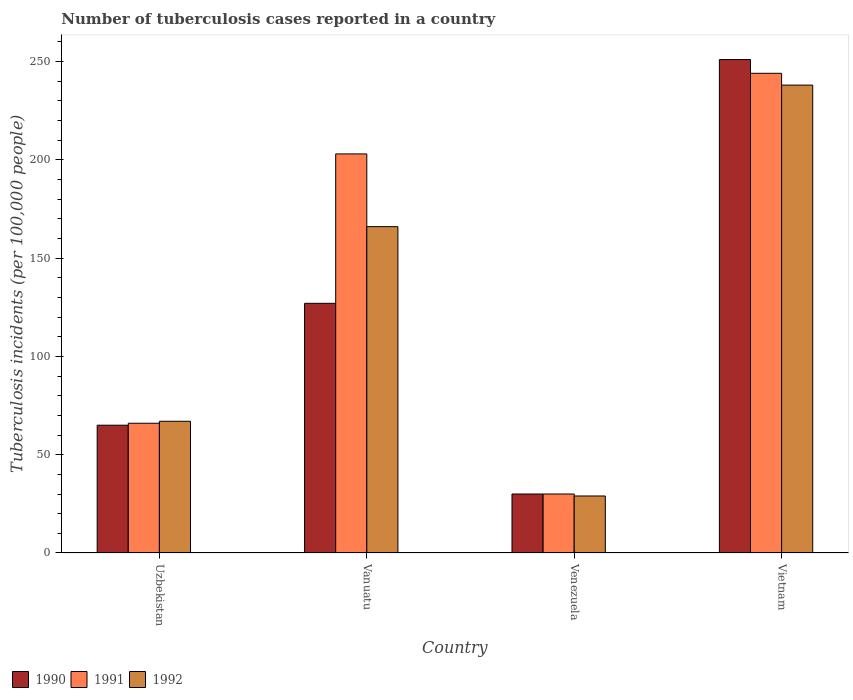How many different coloured bars are there?
Make the answer very short. 3. How many bars are there on the 3rd tick from the left?
Your answer should be compact. 3. What is the label of the 2nd group of bars from the left?
Your answer should be very brief. Vanuatu. What is the number of tuberculosis cases reported in in 1992 in Vietnam?
Provide a short and direct response. 238. Across all countries, what is the maximum number of tuberculosis cases reported in in 1992?
Your answer should be compact. 238. Across all countries, what is the minimum number of tuberculosis cases reported in in 1991?
Make the answer very short. 30. In which country was the number of tuberculosis cases reported in in 1992 maximum?
Provide a succinct answer. Vietnam. In which country was the number of tuberculosis cases reported in in 1992 minimum?
Make the answer very short. Venezuela. What is the total number of tuberculosis cases reported in in 1992 in the graph?
Provide a succinct answer. 500. What is the difference between the number of tuberculosis cases reported in in 1990 in Venezuela and that in Vietnam?
Keep it short and to the point. -221. What is the difference between the number of tuberculosis cases reported in in 1991 in Venezuela and the number of tuberculosis cases reported in in 1992 in Vanuatu?
Your answer should be very brief. -136. What is the average number of tuberculosis cases reported in in 1992 per country?
Provide a short and direct response. 125. What is the difference between the number of tuberculosis cases reported in of/in 1992 and number of tuberculosis cases reported in of/in 1991 in Venezuela?
Your answer should be compact. -1. In how many countries, is the number of tuberculosis cases reported in in 1992 greater than 90?
Your response must be concise. 2. What is the ratio of the number of tuberculosis cases reported in in 1992 in Vanuatu to that in Venezuela?
Give a very brief answer. 5.72. Is the number of tuberculosis cases reported in in 1990 in Uzbekistan less than that in Vietnam?
Offer a very short reply. Yes. Is the difference between the number of tuberculosis cases reported in in 1992 in Uzbekistan and Vanuatu greater than the difference between the number of tuberculosis cases reported in in 1991 in Uzbekistan and Vanuatu?
Provide a short and direct response. Yes. What is the difference between the highest and the second highest number of tuberculosis cases reported in in 1990?
Offer a terse response. -186. What is the difference between the highest and the lowest number of tuberculosis cases reported in in 1990?
Ensure brevity in your answer.  221. In how many countries, is the number of tuberculosis cases reported in in 1991 greater than the average number of tuberculosis cases reported in in 1991 taken over all countries?
Provide a succinct answer. 2. Is the sum of the number of tuberculosis cases reported in in 1992 in Uzbekistan and Venezuela greater than the maximum number of tuberculosis cases reported in in 1990 across all countries?
Your answer should be compact. No. What does the 1st bar from the left in Uzbekistan represents?
Give a very brief answer. 1990. What does the 2nd bar from the right in Uzbekistan represents?
Offer a very short reply. 1991. Is it the case that in every country, the sum of the number of tuberculosis cases reported in in 1990 and number of tuberculosis cases reported in in 1992 is greater than the number of tuberculosis cases reported in in 1991?
Give a very brief answer. Yes. Are all the bars in the graph horizontal?
Provide a succinct answer. No. What is the difference between two consecutive major ticks on the Y-axis?
Provide a short and direct response. 50. Does the graph contain any zero values?
Your answer should be compact. No. Where does the legend appear in the graph?
Provide a short and direct response. Bottom left. How many legend labels are there?
Keep it short and to the point. 3. What is the title of the graph?
Offer a very short reply. Number of tuberculosis cases reported in a country. Does "1965" appear as one of the legend labels in the graph?
Offer a very short reply. No. What is the label or title of the X-axis?
Your answer should be compact. Country. What is the label or title of the Y-axis?
Ensure brevity in your answer.  Tuberculosis incidents (per 100,0 people). What is the Tuberculosis incidents (per 100,000 people) of 1990 in Uzbekistan?
Your response must be concise. 65. What is the Tuberculosis incidents (per 100,000 people) of 1991 in Uzbekistan?
Make the answer very short. 66. What is the Tuberculosis incidents (per 100,000 people) of 1990 in Vanuatu?
Offer a terse response. 127. What is the Tuberculosis incidents (per 100,000 people) of 1991 in Vanuatu?
Make the answer very short. 203. What is the Tuberculosis incidents (per 100,000 people) of 1992 in Vanuatu?
Provide a succinct answer. 166. What is the Tuberculosis incidents (per 100,000 people) of 1990 in Venezuela?
Offer a very short reply. 30. What is the Tuberculosis incidents (per 100,000 people) of 1991 in Venezuela?
Provide a short and direct response. 30. What is the Tuberculosis incidents (per 100,000 people) in 1992 in Venezuela?
Give a very brief answer. 29. What is the Tuberculosis incidents (per 100,000 people) of 1990 in Vietnam?
Give a very brief answer. 251. What is the Tuberculosis incidents (per 100,000 people) in 1991 in Vietnam?
Your answer should be compact. 244. What is the Tuberculosis incidents (per 100,000 people) of 1992 in Vietnam?
Your answer should be compact. 238. Across all countries, what is the maximum Tuberculosis incidents (per 100,000 people) of 1990?
Give a very brief answer. 251. Across all countries, what is the maximum Tuberculosis incidents (per 100,000 people) in 1991?
Your answer should be very brief. 244. Across all countries, what is the maximum Tuberculosis incidents (per 100,000 people) of 1992?
Your answer should be compact. 238. Across all countries, what is the minimum Tuberculosis incidents (per 100,000 people) in 1992?
Ensure brevity in your answer.  29. What is the total Tuberculosis incidents (per 100,000 people) in 1990 in the graph?
Make the answer very short. 473. What is the total Tuberculosis incidents (per 100,000 people) in 1991 in the graph?
Provide a short and direct response. 543. What is the total Tuberculosis incidents (per 100,000 people) of 1992 in the graph?
Make the answer very short. 500. What is the difference between the Tuberculosis incidents (per 100,000 people) in 1990 in Uzbekistan and that in Vanuatu?
Give a very brief answer. -62. What is the difference between the Tuberculosis incidents (per 100,000 people) in 1991 in Uzbekistan and that in Vanuatu?
Give a very brief answer. -137. What is the difference between the Tuberculosis incidents (per 100,000 people) of 1992 in Uzbekistan and that in Vanuatu?
Offer a terse response. -99. What is the difference between the Tuberculosis incidents (per 100,000 people) of 1991 in Uzbekistan and that in Venezuela?
Ensure brevity in your answer.  36. What is the difference between the Tuberculosis incidents (per 100,000 people) in 1992 in Uzbekistan and that in Venezuela?
Ensure brevity in your answer.  38. What is the difference between the Tuberculosis incidents (per 100,000 people) of 1990 in Uzbekistan and that in Vietnam?
Keep it short and to the point. -186. What is the difference between the Tuberculosis incidents (per 100,000 people) in 1991 in Uzbekistan and that in Vietnam?
Keep it short and to the point. -178. What is the difference between the Tuberculosis incidents (per 100,000 people) of 1992 in Uzbekistan and that in Vietnam?
Provide a short and direct response. -171. What is the difference between the Tuberculosis incidents (per 100,000 people) of 1990 in Vanuatu and that in Venezuela?
Your answer should be very brief. 97. What is the difference between the Tuberculosis incidents (per 100,000 people) of 1991 in Vanuatu and that in Venezuela?
Your answer should be very brief. 173. What is the difference between the Tuberculosis incidents (per 100,000 people) in 1992 in Vanuatu and that in Venezuela?
Your answer should be compact. 137. What is the difference between the Tuberculosis incidents (per 100,000 people) in 1990 in Vanuatu and that in Vietnam?
Your answer should be very brief. -124. What is the difference between the Tuberculosis incidents (per 100,000 people) of 1991 in Vanuatu and that in Vietnam?
Your answer should be compact. -41. What is the difference between the Tuberculosis incidents (per 100,000 people) of 1992 in Vanuatu and that in Vietnam?
Offer a very short reply. -72. What is the difference between the Tuberculosis incidents (per 100,000 people) in 1990 in Venezuela and that in Vietnam?
Provide a succinct answer. -221. What is the difference between the Tuberculosis incidents (per 100,000 people) of 1991 in Venezuela and that in Vietnam?
Your answer should be very brief. -214. What is the difference between the Tuberculosis incidents (per 100,000 people) of 1992 in Venezuela and that in Vietnam?
Offer a very short reply. -209. What is the difference between the Tuberculosis incidents (per 100,000 people) of 1990 in Uzbekistan and the Tuberculosis incidents (per 100,000 people) of 1991 in Vanuatu?
Your answer should be compact. -138. What is the difference between the Tuberculosis incidents (per 100,000 people) in 1990 in Uzbekistan and the Tuberculosis incidents (per 100,000 people) in 1992 in Vanuatu?
Make the answer very short. -101. What is the difference between the Tuberculosis incidents (per 100,000 people) in 1991 in Uzbekistan and the Tuberculosis incidents (per 100,000 people) in 1992 in Vanuatu?
Ensure brevity in your answer.  -100. What is the difference between the Tuberculosis incidents (per 100,000 people) of 1990 in Uzbekistan and the Tuberculosis incidents (per 100,000 people) of 1992 in Venezuela?
Provide a succinct answer. 36. What is the difference between the Tuberculosis incidents (per 100,000 people) in 1990 in Uzbekistan and the Tuberculosis incidents (per 100,000 people) in 1991 in Vietnam?
Provide a short and direct response. -179. What is the difference between the Tuberculosis incidents (per 100,000 people) in 1990 in Uzbekistan and the Tuberculosis incidents (per 100,000 people) in 1992 in Vietnam?
Your answer should be compact. -173. What is the difference between the Tuberculosis incidents (per 100,000 people) of 1991 in Uzbekistan and the Tuberculosis incidents (per 100,000 people) of 1992 in Vietnam?
Provide a succinct answer. -172. What is the difference between the Tuberculosis incidents (per 100,000 people) of 1990 in Vanuatu and the Tuberculosis incidents (per 100,000 people) of 1991 in Venezuela?
Make the answer very short. 97. What is the difference between the Tuberculosis incidents (per 100,000 people) of 1991 in Vanuatu and the Tuberculosis incidents (per 100,000 people) of 1992 in Venezuela?
Offer a very short reply. 174. What is the difference between the Tuberculosis incidents (per 100,000 people) in 1990 in Vanuatu and the Tuberculosis incidents (per 100,000 people) in 1991 in Vietnam?
Make the answer very short. -117. What is the difference between the Tuberculosis incidents (per 100,000 people) of 1990 in Vanuatu and the Tuberculosis incidents (per 100,000 people) of 1992 in Vietnam?
Ensure brevity in your answer.  -111. What is the difference between the Tuberculosis incidents (per 100,000 people) in 1991 in Vanuatu and the Tuberculosis incidents (per 100,000 people) in 1992 in Vietnam?
Keep it short and to the point. -35. What is the difference between the Tuberculosis incidents (per 100,000 people) of 1990 in Venezuela and the Tuberculosis incidents (per 100,000 people) of 1991 in Vietnam?
Your response must be concise. -214. What is the difference between the Tuberculosis incidents (per 100,000 people) in 1990 in Venezuela and the Tuberculosis incidents (per 100,000 people) in 1992 in Vietnam?
Keep it short and to the point. -208. What is the difference between the Tuberculosis incidents (per 100,000 people) in 1991 in Venezuela and the Tuberculosis incidents (per 100,000 people) in 1992 in Vietnam?
Ensure brevity in your answer.  -208. What is the average Tuberculosis incidents (per 100,000 people) in 1990 per country?
Provide a succinct answer. 118.25. What is the average Tuberculosis incidents (per 100,000 people) in 1991 per country?
Your answer should be very brief. 135.75. What is the average Tuberculosis incidents (per 100,000 people) of 1992 per country?
Offer a very short reply. 125. What is the difference between the Tuberculosis incidents (per 100,000 people) of 1991 and Tuberculosis incidents (per 100,000 people) of 1992 in Uzbekistan?
Your response must be concise. -1. What is the difference between the Tuberculosis incidents (per 100,000 people) of 1990 and Tuberculosis incidents (per 100,000 people) of 1991 in Vanuatu?
Offer a terse response. -76. What is the difference between the Tuberculosis incidents (per 100,000 people) of 1990 and Tuberculosis incidents (per 100,000 people) of 1992 in Vanuatu?
Offer a very short reply. -39. What is the difference between the Tuberculosis incidents (per 100,000 people) in 1990 and Tuberculosis incidents (per 100,000 people) in 1991 in Venezuela?
Your answer should be compact. 0. What is the difference between the Tuberculosis incidents (per 100,000 people) in 1990 and Tuberculosis incidents (per 100,000 people) in 1992 in Venezuela?
Ensure brevity in your answer.  1. What is the difference between the Tuberculosis incidents (per 100,000 people) of 1990 and Tuberculosis incidents (per 100,000 people) of 1991 in Vietnam?
Offer a terse response. 7. What is the difference between the Tuberculosis incidents (per 100,000 people) in 1990 and Tuberculosis incidents (per 100,000 people) in 1992 in Vietnam?
Your response must be concise. 13. What is the ratio of the Tuberculosis incidents (per 100,000 people) in 1990 in Uzbekistan to that in Vanuatu?
Keep it short and to the point. 0.51. What is the ratio of the Tuberculosis incidents (per 100,000 people) of 1991 in Uzbekistan to that in Vanuatu?
Make the answer very short. 0.33. What is the ratio of the Tuberculosis incidents (per 100,000 people) in 1992 in Uzbekistan to that in Vanuatu?
Your answer should be compact. 0.4. What is the ratio of the Tuberculosis incidents (per 100,000 people) of 1990 in Uzbekistan to that in Venezuela?
Ensure brevity in your answer.  2.17. What is the ratio of the Tuberculosis incidents (per 100,000 people) in 1992 in Uzbekistan to that in Venezuela?
Provide a succinct answer. 2.31. What is the ratio of the Tuberculosis incidents (per 100,000 people) of 1990 in Uzbekistan to that in Vietnam?
Give a very brief answer. 0.26. What is the ratio of the Tuberculosis incidents (per 100,000 people) in 1991 in Uzbekistan to that in Vietnam?
Offer a terse response. 0.27. What is the ratio of the Tuberculosis incidents (per 100,000 people) of 1992 in Uzbekistan to that in Vietnam?
Keep it short and to the point. 0.28. What is the ratio of the Tuberculosis incidents (per 100,000 people) of 1990 in Vanuatu to that in Venezuela?
Give a very brief answer. 4.23. What is the ratio of the Tuberculosis incidents (per 100,000 people) in 1991 in Vanuatu to that in Venezuela?
Make the answer very short. 6.77. What is the ratio of the Tuberculosis incidents (per 100,000 people) in 1992 in Vanuatu to that in Venezuela?
Offer a terse response. 5.72. What is the ratio of the Tuberculosis incidents (per 100,000 people) in 1990 in Vanuatu to that in Vietnam?
Your answer should be compact. 0.51. What is the ratio of the Tuberculosis incidents (per 100,000 people) of 1991 in Vanuatu to that in Vietnam?
Provide a succinct answer. 0.83. What is the ratio of the Tuberculosis incidents (per 100,000 people) of 1992 in Vanuatu to that in Vietnam?
Keep it short and to the point. 0.7. What is the ratio of the Tuberculosis incidents (per 100,000 people) of 1990 in Venezuela to that in Vietnam?
Give a very brief answer. 0.12. What is the ratio of the Tuberculosis incidents (per 100,000 people) of 1991 in Venezuela to that in Vietnam?
Keep it short and to the point. 0.12. What is the ratio of the Tuberculosis incidents (per 100,000 people) of 1992 in Venezuela to that in Vietnam?
Keep it short and to the point. 0.12. What is the difference between the highest and the second highest Tuberculosis incidents (per 100,000 people) in 1990?
Offer a very short reply. 124. What is the difference between the highest and the second highest Tuberculosis incidents (per 100,000 people) in 1991?
Offer a terse response. 41. What is the difference between the highest and the second highest Tuberculosis incidents (per 100,000 people) in 1992?
Provide a short and direct response. 72. What is the difference between the highest and the lowest Tuberculosis incidents (per 100,000 people) of 1990?
Provide a short and direct response. 221. What is the difference between the highest and the lowest Tuberculosis incidents (per 100,000 people) of 1991?
Offer a very short reply. 214. What is the difference between the highest and the lowest Tuberculosis incidents (per 100,000 people) of 1992?
Keep it short and to the point. 209. 